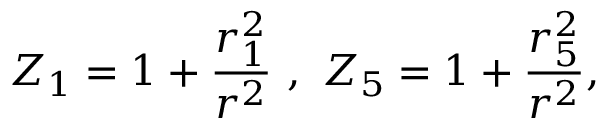<formula> <loc_0><loc_0><loc_500><loc_500>Z _ { 1 } = 1 + \frac { r _ { 1 } ^ { 2 } } { r ^ { 2 } } \ , \ Z _ { 5 } = 1 + \frac { r _ { 5 } ^ { 2 } } { r ^ { 2 } } ,</formula> 